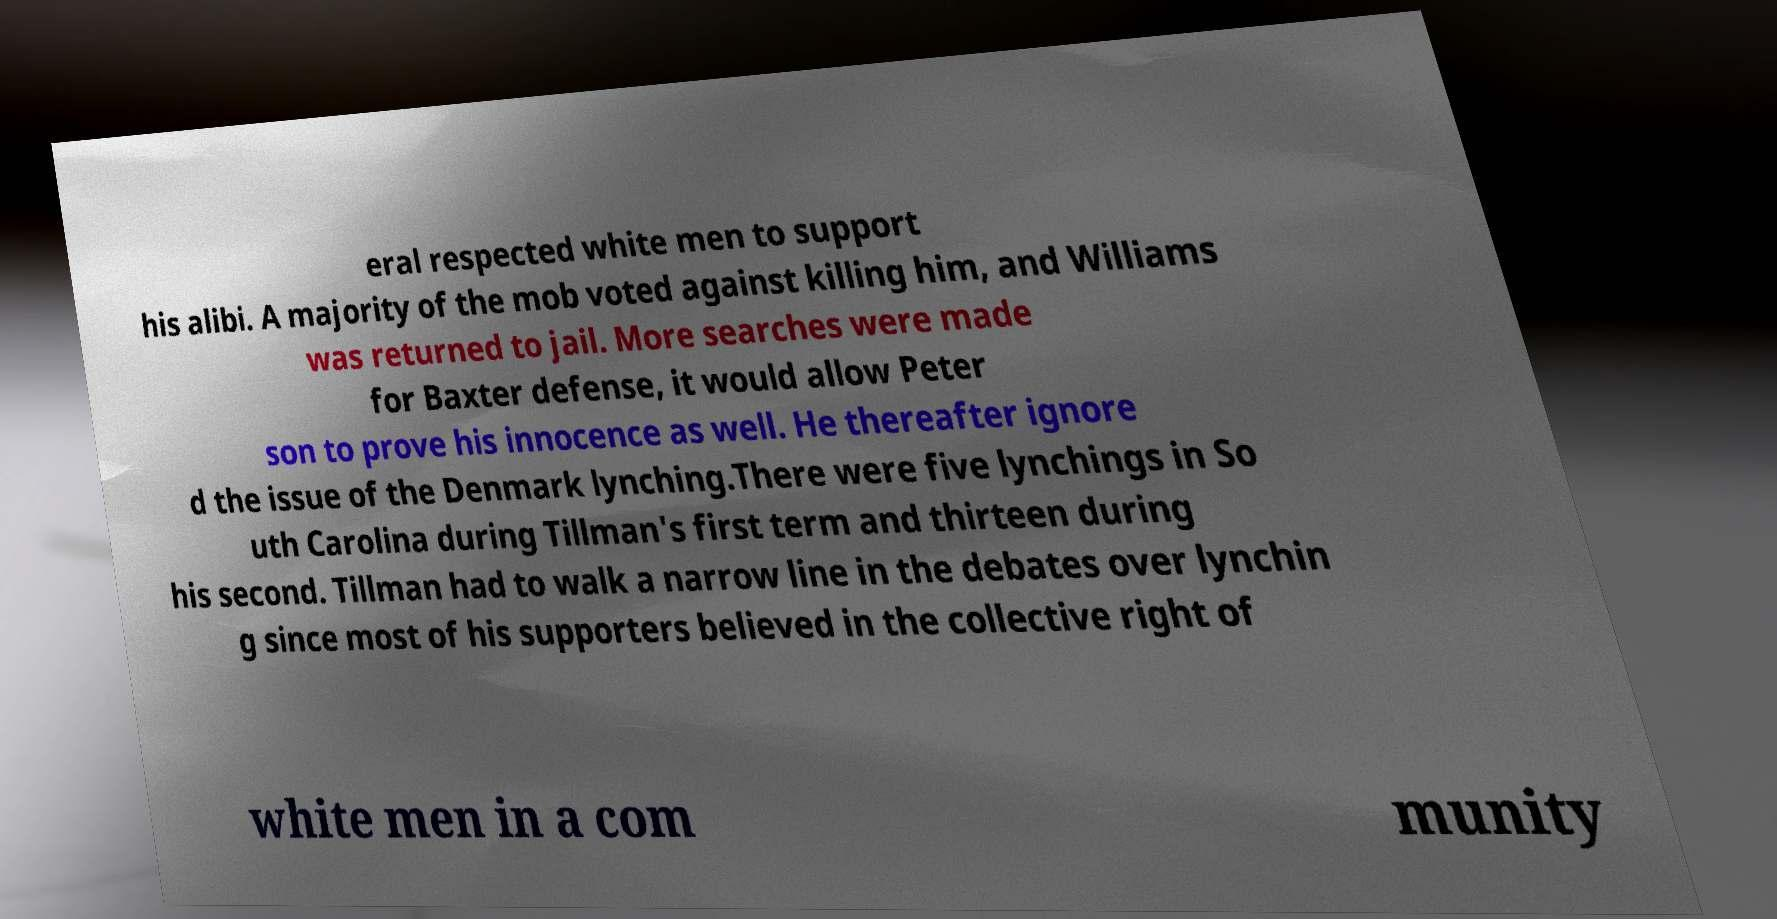I need the written content from this picture converted into text. Can you do that? eral respected white men to support his alibi. A majority of the mob voted against killing him, and Williams was returned to jail. More searches were made for Baxter defense, it would allow Peter son to prove his innocence as well. He thereafter ignore d the issue of the Denmark lynching.There were five lynchings in So uth Carolina during Tillman's first term and thirteen during his second. Tillman had to walk a narrow line in the debates over lynchin g since most of his supporters believed in the collective right of white men in a com munity 